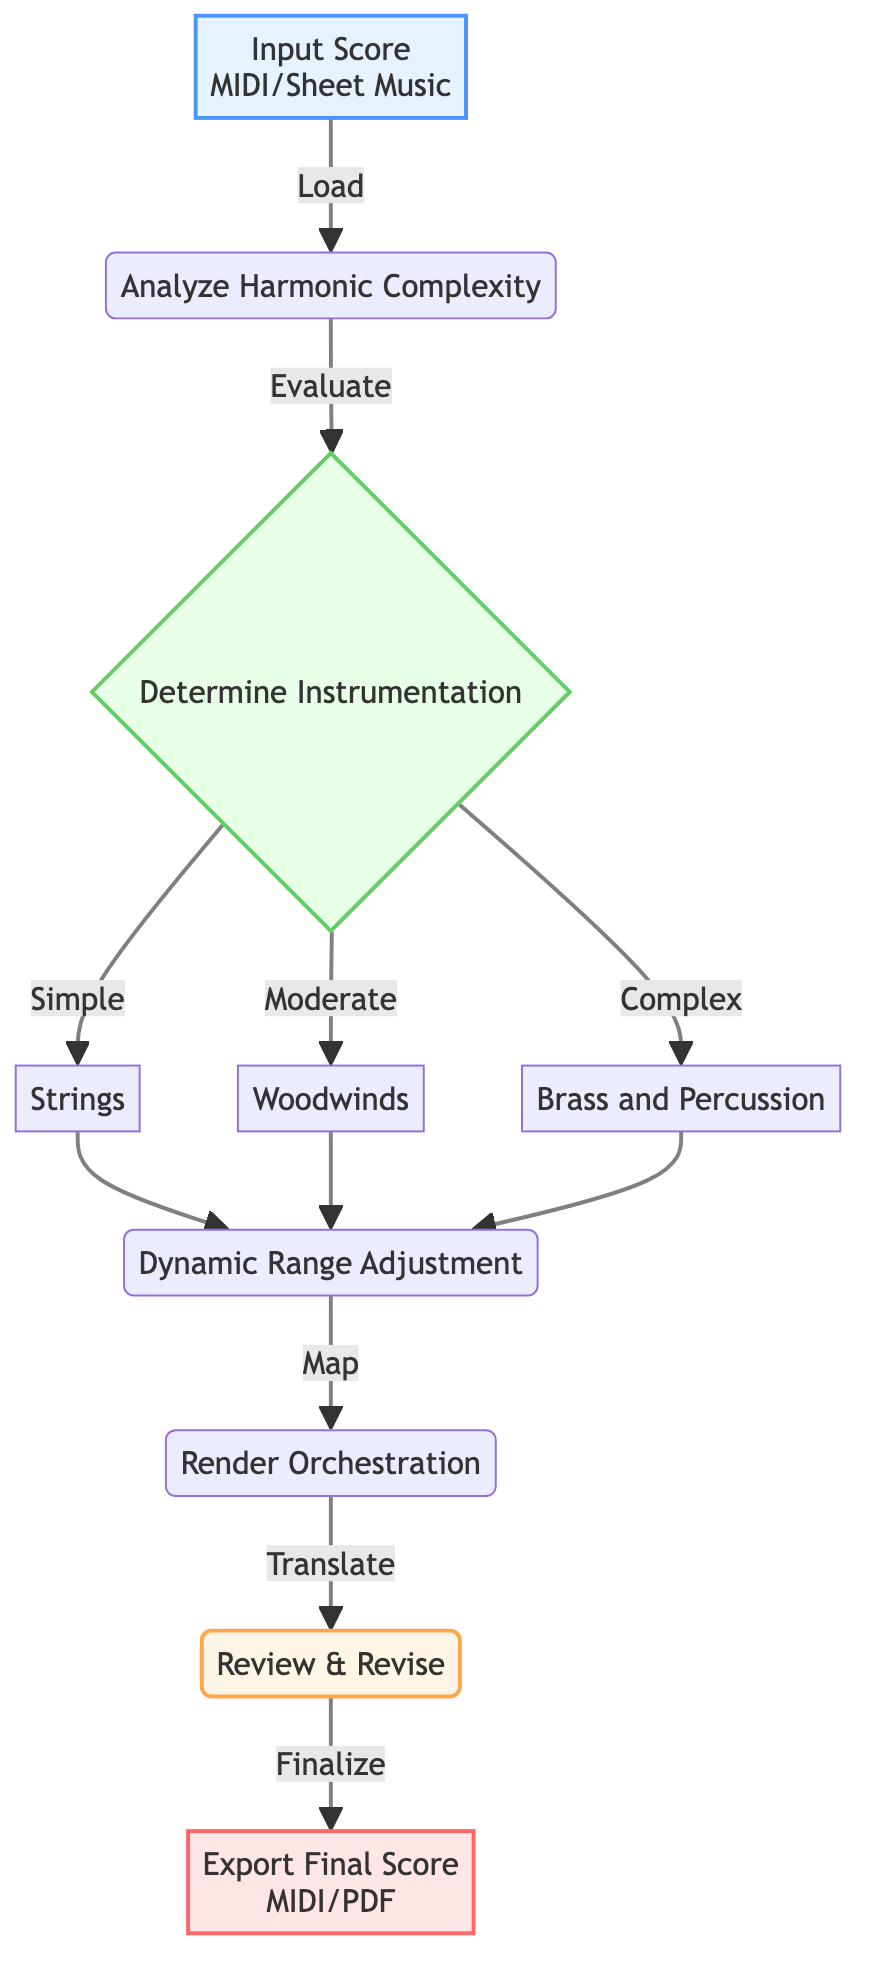What is the input data type in the diagram? The diagram specifies that the input data type is either MIDI or Sheet Music, as stated in the description for the "Input Score" node.
Answer: MIDI/Sheet Music What is the first process step after analyzing harmonic complexity? Once the "Analyze Harmonic Complexity" process step is completed, the next step is to "Determine Instrumentation," which follows from the analysis.
Answer: Determine Instrumentation Which decision splits into three different instrumental categories? The decision node labeled "Determine Instrumentation" is where the flowchart splits into three categories: Simple, Moderate, and Complex instruments.
Answer: Determine Instrumentation What is the final output format of the orchestrated score? The final output format indicated in the "Export Final Score" node is either MIDI or PDF, which represents the completed orchestration.
Answer: MIDI/PDF How many process nodes are present in the flowchart? There are four process nodes in the flowchart: "Analyze Harmonic Complexity," "Dynamic Range Adjustment," "Render Orchestration," and "Review & Revise."
Answer: Four What happens after instrument selection based on harmonic density? After the selection of instruments based on harmonic density, the flow proceeds to the "Dynamic Range Adjustment" process, where adjustments to the dynamic range are made.
Answer: Dynamic Range Adjustment Which instruments correspond to the "Moderate" complexity level? The instruments corresponding to the "Moderate" complexity level, as noted in the decision node, are Woodwinds.
Answer: Woodwinds What is the software used for rendering orchestration? The software indicated for the "Render Orchestration" process is either Sibelius or Finale, as specified in the description of that node.
Answer: Sibelius/Finale What does the "Review & Revise" process involve? The "Review & Revise" node involves manually reviewing the orchestrated parts and making necessary revisions to ensure musicality, which is indicated in its description.
Answer: Audio Playback 